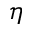Convert formula to latex. <formula><loc_0><loc_0><loc_500><loc_500>\eta</formula> 